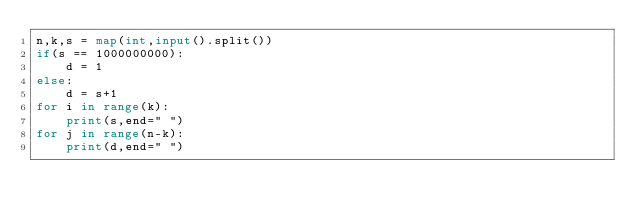<code> <loc_0><loc_0><loc_500><loc_500><_Python_>n,k,s = map(int,input().split())
if(s == 1000000000):
    d = 1
else:
    d = s+1
for i in range(k):
    print(s,end=" ")
for j in range(n-k):
    print(d,end=" ")</code> 